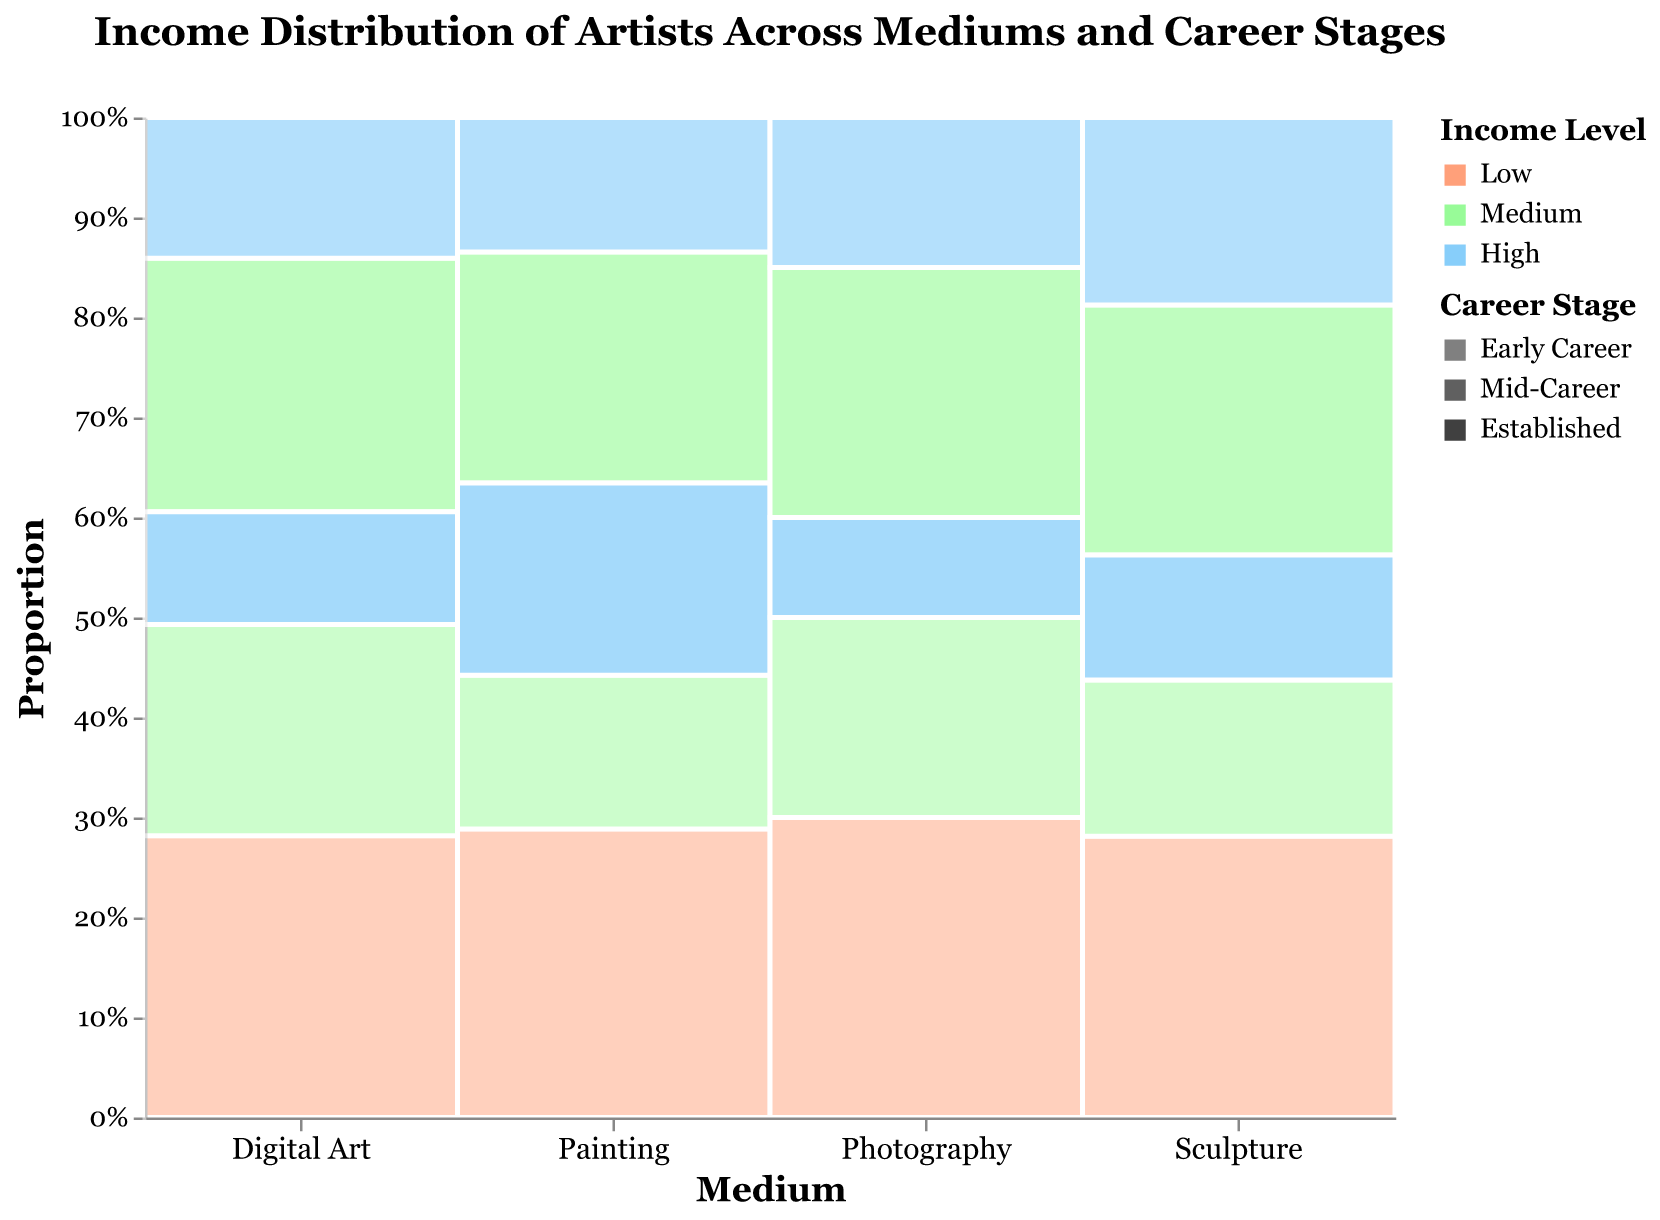What is the title of the plot? The title is usually displayed at the top of the plot and helps to understand the overall subject. Here, the required information is "Income Distribution of Artists Across Mediums and Career Stages".
Answer: Income Distribution of Artists Across Mediums and Career Stages Which medium has the highest count of early-career artists with a low income? To answer this, identify the different mediums and check the portion representing the early-career artists with a low income. The bigger the portion, the higher the count.
Answer: Digital Art What's the percentage trend for mid-career artists with a high income across different mediums? To answer this, observe the sections representing mid-career artists with high income for each medium and compare their proportions visually.
Answer: The percentage decreases from Painting to Sculpture to Digital Art to Photography Which medium has the largest proportion of artists with a medium income level? Identify which medium has a larger area in the section colored for medium income. This is done by visually comparing the sections.
Answer: Digital Art What can you say about the income distribution of established artists in the Painting medium? Look specifically at the Painting medium and check the distribution of proportions among established artists.
Answer: The majority of established artists in Painting have a high income Compare the proportion of early-career artists with medium income between Digital Art and Photography. Identify the sections representing early-career artists with medium income in both Digital Art and Photography and compare their sizes.
Answer: Digital Art has a higher proportion compared to Photography Which career stage and income level has the smallest representation in Sculpture? Look at the Sculpture section and identify the smallest area among all career stages and income levels.
Answer: Established artists with a high income stage What's the dominant income level for mid-career artists in Photography? Look at the mid-career section of the Photography medium and identify which income level has the largest area.
Answer: Medium How does the high income level vary among established artists across different mediums? Examine the high-income proportions for established artists in all mediums and compare them.
Answer: Painting > Digital Art > Photography > Sculpture 